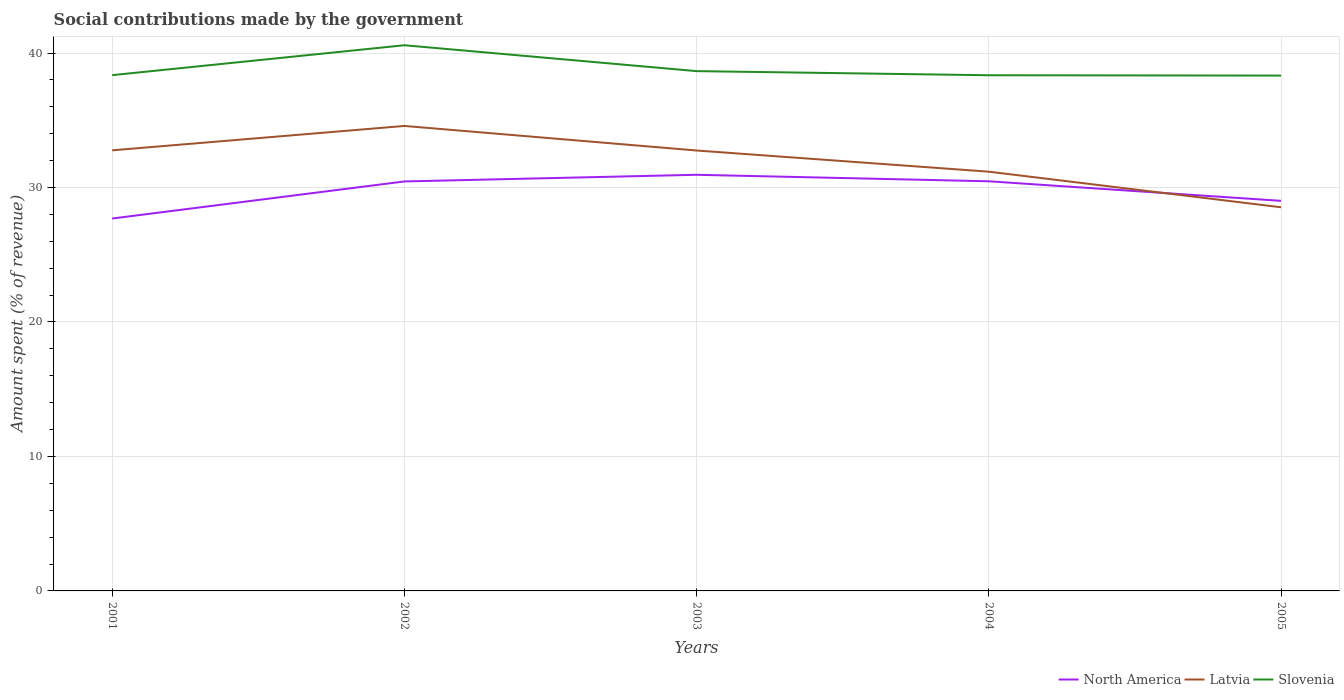How many different coloured lines are there?
Offer a terse response. 3. Does the line corresponding to Latvia intersect with the line corresponding to North America?
Ensure brevity in your answer.  Yes. Across all years, what is the maximum amount spent (in %) on social contributions in Slovenia?
Your response must be concise. 38.33. In which year was the amount spent (in %) on social contributions in Latvia maximum?
Offer a terse response. 2005. What is the total amount spent (in %) on social contributions in North America in the graph?
Offer a very short reply. -2.76. What is the difference between the highest and the second highest amount spent (in %) on social contributions in North America?
Your response must be concise. 3.25. What is the difference between the highest and the lowest amount spent (in %) on social contributions in Slovenia?
Offer a very short reply. 1. What is the difference between two consecutive major ticks on the Y-axis?
Make the answer very short. 10. Does the graph contain grids?
Your answer should be compact. Yes. How many legend labels are there?
Your response must be concise. 3. How are the legend labels stacked?
Ensure brevity in your answer.  Horizontal. What is the title of the graph?
Provide a short and direct response. Social contributions made by the government. What is the label or title of the X-axis?
Provide a short and direct response. Years. What is the label or title of the Y-axis?
Your answer should be compact. Amount spent (% of revenue). What is the Amount spent (% of revenue) of North America in 2001?
Provide a short and direct response. 27.69. What is the Amount spent (% of revenue) in Latvia in 2001?
Provide a succinct answer. 32.77. What is the Amount spent (% of revenue) in Slovenia in 2001?
Provide a short and direct response. 38.36. What is the Amount spent (% of revenue) in North America in 2002?
Make the answer very short. 30.45. What is the Amount spent (% of revenue) of Latvia in 2002?
Give a very brief answer. 34.58. What is the Amount spent (% of revenue) of Slovenia in 2002?
Your answer should be compact. 40.58. What is the Amount spent (% of revenue) of North America in 2003?
Your response must be concise. 30.95. What is the Amount spent (% of revenue) in Latvia in 2003?
Your response must be concise. 32.75. What is the Amount spent (% of revenue) of Slovenia in 2003?
Provide a succinct answer. 38.66. What is the Amount spent (% of revenue) of North America in 2004?
Keep it short and to the point. 30.47. What is the Amount spent (% of revenue) of Latvia in 2004?
Your answer should be very brief. 31.18. What is the Amount spent (% of revenue) in Slovenia in 2004?
Provide a short and direct response. 38.35. What is the Amount spent (% of revenue) of North America in 2005?
Ensure brevity in your answer.  29.01. What is the Amount spent (% of revenue) in Latvia in 2005?
Make the answer very short. 28.53. What is the Amount spent (% of revenue) of Slovenia in 2005?
Your answer should be very brief. 38.33. Across all years, what is the maximum Amount spent (% of revenue) in North America?
Give a very brief answer. 30.95. Across all years, what is the maximum Amount spent (% of revenue) of Latvia?
Your response must be concise. 34.58. Across all years, what is the maximum Amount spent (% of revenue) of Slovenia?
Ensure brevity in your answer.  40.58. Across all years, what is the minimum Amount spent (% of revenue) in North America?
Keep it short and to the point. 27.69. Across all years, what is the minimum Amount spent (% of revenue) in Latvia?
Offer a terse response. 28.53. Across all years, what is the minimum Amount spent (% of revenue) in Slovenia?
Provide a succinct answer. 38.33. What is the total Amount spent (% of revenue) in North America in the graph?
Offer a terse response. 148.57. What is the total Amount spent (% of revenue) in Latvia in the graph?
Make the answer very short. 159.81. What is the total Amount spent (% of revenue) in Slovenia in the graph?
Give a very brief answer. 194.28. What is the difference between the Amount spent (% of revenue) of North America in 2001 and that in 2002?
Offer a terse response. -2.76. What is the difference between the Amount spent (% of revenue) in Latvia in 2001 and that in 2002?
Your answer should be very brief. -1.81. What is the difference between the Amount spent (% of revenue) in Slovenia in 2001 and that in 2002?
Offer a terse response. -2.22. What is the difference between the Amount spent (% of revenue) in North America in 2001 and that in 2003?
Make the answer very short. -3.25. What is the difference between the Amount spent (% of revenue) in Latvia in 2001 and that in 2003?
Provide a short and direct response. 0.01. What is the difference between the Amount spent (% of revenue) of Slovenia in 2001 and that in 2003?
Keep it short and to the point. -0.3. What is the difference between the Amount spent (% of revenue) of North America in 2001 and that in 2004?
Offer a terse response. -2.77. What is the difference between the Amount spent (% of revenue) in Latvia in 2001 and that in 2004?
Keep it short and to the point. 1.59. What is the difference between the Amount spent (% of revenue) in Slovenia in 2001 and that in 2004?
Keep it short and to the point. 0.01. What is the difference between the Amount spent (% of revenue) in North America in 2001 and that in 2005?
Ensure brevity in your answer.  -1.32. What is the difference between the Amount spent (% of revenue) in Latvia in 2001 and that in 2005?
Your answer should be very brief. 4.24. What is the difference between the Amount spent (% of revenue) in Slovenia in 2001 and that in 2005?
Your response must be concise. 0.03. What is the difference between the Amount spent (% of revenue) of North America in 2002 and that in 2003?
Your response must be concise. -0.5. What is the difference between the Amount spent (% of revenue) of Latvia in 2002 and that in 2003?
Give a very brief answer. 1.83. What is the difference between the Amount spent (% of revenue) of Slovenia in 2002 and that in 2003?
Give a very brief answer. 1.92. What is the difference between the Amount spent (% of revenue) in North America in 2002 and that in 2004?
Ensure brevity in your answer.  -0.01. What is the difference between the Amount spent (% of revenue) in Latvia in 2002 and that in 2004?
Offer a very short reply. 3.4. What is the difference between the Amount spent (% of revenue) in Slovenia in 2002 and that in 2004?
Keep it short and to the point. 2.23. What is the difference between the Amount spent (% of revenue) in North America in 2002 and that in 2005?
Provide a succinct answer. 1.44. What is the difference between the Amount spent (% of revenue) of Latvia in 2002 and that in 2005?
Ensure brevity in your answer.  6.05. What is the difference between the Amount spent (% of revenue) in Slovenia in 2002 and that in 2005?
Provide a succinct answer. 2.26. What is the difference between the Amount spent (% of revenue) of North America in 2003 and that in 2004?
Provide a short and direct response. 0.48. What is the difference between the Amount spent (% of revenue) in Latvia in 2003 and that in 2004?
Your response must be concise. 1.58. What is the difference between the Amount spent (% of revenue) of Slovenia in 2003 and that in 2004?
Ensure brevity in your answer.  0.31. What is the difference between the Amount spent (% of revenue) in North America in 2003 and that in 2005?
Offer a very short reply. 1.94. What is the difference between the Amount spent (% of revenue) in Latvia in 2003 and that in 2005?
Offer a terse response. 4.22. What is the difference between the Amount spent (% of revenue) of Slovenia in 2003 and that in 2005?
Provide a short and direct response. 0.33. What is the difference between the Amount spent (% of revenue) in North America in 2004 and that in 2005?
Keep it short and to the point. 1.46. What is the difference between the Amount spent (% of revenue) of Latvia in 2004 and that in 2005?
Your response must be concise. 2.65. What is the difference between the Amount spent (% of revenue) of Slovenia in 2004 and that in 2005?
Make the answer very short. 0.02. What is the difference between the Amount spent (% of revenue) of North America in 2001 and the Amount spent (% of revenue) of Latvia in 2002?
Provide a succinct answer. -6.89. What is the difference between the Amount spent (% of revenue) in North America in 2001 and the Amount spent (% of revenue) in Slovenia in 2002?
Your response must be concise. -12.89. What is the difference between the Amount spent (% of revenue) in Latvia in 2001 and the Amount spent (% of revenue) in Slovenia in 2002?
Keep it short and to the point. -7.82. What is the difference between the Amount spent (% of revenue) in North America in 2001 and the Amount spent (% of revenue) in Latvia in 2003?
Your response must be concise. -5.06. What is the difference between the Amount spent (% of revenue) in North America in 2001 and the Amount spent (% of revenue) in Slovenia in 2003?
Your answer should be very brief. -10.96. What is the difference between the Amount spent (% of revenue) in Latvia in 2001 and the Amount spent (% of revenue) in Slovenia in 2003?
Your answer should be very brief. -5.89. What is the difference between the Amount spent (% of revenue) of North America in 2001 and the Amount spent (% of revenue) of Latvia in 2004?
Keep it short and to the point. -3.48. What is the difference between the Amount spent (% of revenue) in North America in 2001 and the Amount spent (% of revenue) in Slovenia in 2004?
Provide a short and direct response. -10.66. What is the difference between the Amount spent (% of revenue) in Latvia in 2001 and the Amount spent (% of revenue) in Slovenia in 2004?
Keep it short and to the point. -5.58. What is the difference between the Amount spent (% of revenue) in North America in 2001 and the Amount spent (% of revenue) in Latvia in 2005?
Ensure brevity in your answer.  -0.84. What is the difference between the Amount spent (% of revenue) of North America in 2001 and the Amount spent (% of revenue) of Slovenia in 2005?
Your response must be concise. -10.63. What is the difference between the Amount spent (% of revenue) of Latvia in 2001 and the Amount spent (% of revenue) of Slovenia in 2005?
Ensure brevity in your answer.  -5.56. What is the difference between the Amount spent (% of revenue) of North America in 2002 and the Amount spent (% of revenue) of Latvia in 2003?
Your answer should be compact. -2.3. What is the difference between the Amount spent (% of revenue) of North America in 2002 and the Amount spent (% of revenue) of Slovenia in 2003?
Provide a short and direct response. -8.2. What is the difference between the Amount spent (% of revenue) in Latvia in 2002 and the Amount spent (% of revenue) in Slovenia in 2003?
Your response must be concise. -4.08. What is the difference between the Amount spent (% of revenue) in North America in 2002 and the Amount spent (% of revenue) in Latvia in 2004?
Offer a very short reply. -0.73. What is the difference between the Amount spent (% of revenue) in North America in 2002 and the Amount spent (% of revenue) in Slovenia in 2004?
Ensure brevity in your answer.  -7.9. What is the difference between the Amount spent (% of revenue) of Latvia in 2002 and the Amount spent (% of revenue) of Slovenia in 2004?
Your answer should be very brief. -3.77. What is the difference between the Amount spent (% of revenue) in North America in 2002 and the Amount spent (% of revenue) in Latvia in 2005?
Keep it short and to the point. 1.92. What is the difference between the Amount spent (% of revenue) in North America in 2002 and the Amount spent (% of revenue) in Slovenia in 2005?
Provide a succinct answer. -7.87. What is the difference between the Amount spent (% of revenue) of Latvia in 2002 and the Amount spent (% of revenue) of Slovenia in 2005?
Ensure brevity in your answer.  -3.75. What is the difference between the Amount spent (% of revenue) of North America in 2003 and the Amount spent (% of revenue) of Latvia in 2004?
Your response must be concise. -0.23. What is the difference between the Amount spent (% of revenue) in North America in 2003 and the Amount spent (% of revenue) in Slovenia in 2004?
Ensure brevity in your answer.  -7.4. What is the difference between the Amount spent (% of revenue) in Latvia in 2003 and the Amount spent (% of revenue) in Slovenia in 2004?
Your answer should be compact. -5.6. What is the difference between the Amount spent (% of revenue) of North America in 2003 and the Amount spent (% of revenue) of Latvia in 2005?
Offer a very short reply. 2.42. What is the difference between the Amount spent (% of revenue) of North America in 2003 and the Amount spent (% of revenue) of Slovenia in 2005?
Provide a short and direct response. -7.38. What is the difference between the Amount spent (% of revenue) of Latvia in 2003 and the Amount spent (% of revenue) of Slovenia in 2005?
Your response must be concise. -5.57. What is the difference between the Amount spent (% of revenue) in North America in 2004 and the Amount spent (% of revenue) in Latvia in 2005?
Offer a very short reply. 1.93. What is the difference between the Amount spent (% of revenue) of North America in 2004 and the Amount spent (% of revenue) of Slovenia in 2005?
Make the answer very short. -7.86. What is the difference between the Amount spent (% of revenue) in Latvia in 2004 and the Amount spent (% of revenue) in Slovenia in 2005?
Make the answer very short. -7.15. What is the average Amount spent (% of revenue) in North America per year?
Give a very brief answer. 29.71. What is the average Amount spent (% of revenue) in Latvia per year?
Offer a very short reply. 31.96. What is the average Amount spent (% of revenue) in Slovenia per year?
Offer a terse response. 38.86. In the year 2001, what is the difference between the Amount spent (% of revenue) in North America and Amount spent (% of revenue) in Latvia?
Provide a succinct answer. -5.07. In the year 2001, what is the difference between the Amount spent (% of revenue) of North America and Amount spent (% of revenue) of Slovenia?
Provide a short and direct response. -10.66. In the year 2001, what is the difference between the Amount spent (% of revenue) of Latvia and Amount spent (% of revenue) of Slovenia?
Your answer should be compact. -5.59. In the year 2002, what is the difference between the Amount spent (% of revenue) in North America and Amount spent (% of revenue) in Latvia?
Your answer should be very brief. -4.13. In the year 2002, what is the difference between the Amount spent (% of revenue) of North America and Amount spent (% of revenue) of Slovenia?
Give a very brief answer. -10.13. In the year 2002, what is the difference between the Amount spent (% of revenue) of Latvia and Amount spent (% of revenue) of Slovenia?
Keep it short and to the point. -6. In the year 2003, what is the difference between the Amount spent (% of revenue) of North America and Amount spent (% of revenue) of Latvia?
Provide a short and direct response. -1.81. In the year 2003, what is the difference between the Amount spent (% of revenue) of North America and Amount spent (% of revenue) of Slovenia?
Your answer should be compact. -7.71. In the year 2003, what is the difference between the Amount spent (% of revenue) in Latvia and Amount spent (% of revenue) in Slovenia?
Give a very brief answer. -5.9. In the year 2004, what is the difference between the Amount spent (% of revenue) in North America and Amount spent (% of revenue) in Latvia?
Your answer should be very brief. -0.71. In the year 2004, what is the difference between the Amount spent (% of revenue) in North America and Amount spent (% of revenue) in Slovenia?
Your response must be concise. -7.89. In the year 2004, what is the difference between the Amount spent (% of revenue) in Latvia and Amount spent (% of revenue) in Slovenia?
Keep it short and to the point. -7.17. In the year 2005, what is the difference between the Amount spent (% of revenue) in North America and Amount spent (% of revenue) in Latvia?
Keep it short and to the point. 0.48. In the year 2005, what is the difference between the Amount spent (% of revenue) in North America and Amount spent (% of revenue) in Slovenia?
Ensure brevity in your answer.  -9.32. In the year 2005, what is the difference between the Amount spent (% of revenue) of Latvia and Amount spent (% of revenue) of Slovenia?
Your answer should be compact. -9.8. What is the ratio of the Amount spent (% of revenue) in North America in 2001 to that in 2002?
Keep it short and to the point. 0.91. What is the ratio of the Amount spent (% of revenue) in Latvia in 2001 to that in 2002?
Offer a terse response. 0.95. What is the ratio of the Amount spent (% of revenue) of Slovenia in 2001 to that in 2002?
Provide a short and direct response. 0.95. What is the ratio of the Amount spent (% of revenue) of North America in 2001 to that in 2003?
Your answer should be very brief. 0.89. What is the ratio of the Amount spent (% of revenue) of Latvia in 2001 to that in 2004?
Your response must be concise. 1.05. What is the ratio of the Amount spent (% of revenue) of Slovenia in 2001 to that in 2004?
Offer a terse response. 1. What is the ratio of the Amount spent (% of revenue) in North America in 2001 to that in 2005?
Make the answer very short. 0.95. What is the ratio of the Amount spent (% of revenue) in Latvia in 2001 to that in 2005?
Offer a very short reply. 1.15. What is the ratio of the Amount spent (% of revenue) in Slovenia in 2001 to that in 2005?
Provide a succinct answer. 1. What is the ratio of the Amount spent (% of revenue) in North America in 2002 to that in 2003?
Offer a very short reply. 0.98. What is the ratio of the Amount spent (% of revenue) in Latvia in 2002 to that in 2003?
Your answer should be very brief. 1.06. What is the ratio of the Amount spent (% of revenue) in Slovenia in 2002 to that in 2003?
Your response must be concise. 1.05. What is the ratio of the Amount spent (% of revenue) of North America in 2002 to that in 2004?
Your answer should be very brief. 1. What is the ratio of the Amount spent (% of revenue) of Latvia in 2002 to that in 2004?
Your answer should be very brief. 1.11. What is the ratio of the Amount spent (% of revenue) of Slovenia in 2002 to that in 2004?
Provide a short and direct response. 1.06. What is the ratio of the Amount spent (% of revenue) in North America in 2002 to that in 2005?
Your answer should be very brief. 1.05. What is the ratio of the Amount spent (% of revenue) of Latvia in 2002 to that in 2005?
Your answer should be compact. 1.21. What is the ratio of the Amount spent (% of revenue) in Slovenia in 2002 to that in 2005?
Keep it short and to the point. 1.06. What is the ratio of the Amount spent (% of revenue) in North America in 2003 to that in 2004?
Your answer should be compact. 1.02. What is the ratio of the Amount spent (% of revenue) of Latvia in 2003 to that in 2004?
Ensure brevity in your answer.  1.05. What is the ratio of the Amount spent (% of revenue) of North America in 2003 to that in 2005?
Make the answer very short. 1.07. What is the ratio of the Amount spent (% of revenue) in Latvia in 2003 to that in 2005?
Your answer should be compact. 1.15. What is the ratio of the Amount spent (% of revenue) in Slovenia in 2003 to that in 2005?
Offer a very short reply. 1.01. What is the ratio of the Amount spent (% of revenue) in North America in 2004 to that in 2005?
Offer a terse response. 1.05. What is the ratio of the Amount spent (% of revenue) of Latvia in 2004 to that in 2005?
Your answer should be compact. 1.09. What is the ratio of the Amount spent (% of revenue) in Slovenia in 2004 to that in 2005?
Your answer should be compact. 1. What is the difference between the highest and the second highest Amount spent (% of revenue) in North America?
Offer a very short reply. 0.48. What is the difference between the highest and the second highest Amount spent (% of revenue) in Latvia?
Your answer should be compact. 1.81. What is the difference between the highest and the second highest Amount spent (% of revenue) in Slovenia?
Your response must be concise. 1.92. What is the difference between the highest and the lowest Amount spent (% of revenue) in North America?
Offer a terse response. 3.25. What is the difference between the highest and the lowest Amount spent (% of revenue) of Latvia?
Ensure brevity in your answer.  6.05. What is the difference between the highest and the lowest Amount spent (% of revenue) of Slovenia?
Ensure brevity in your answer.  2.26. 